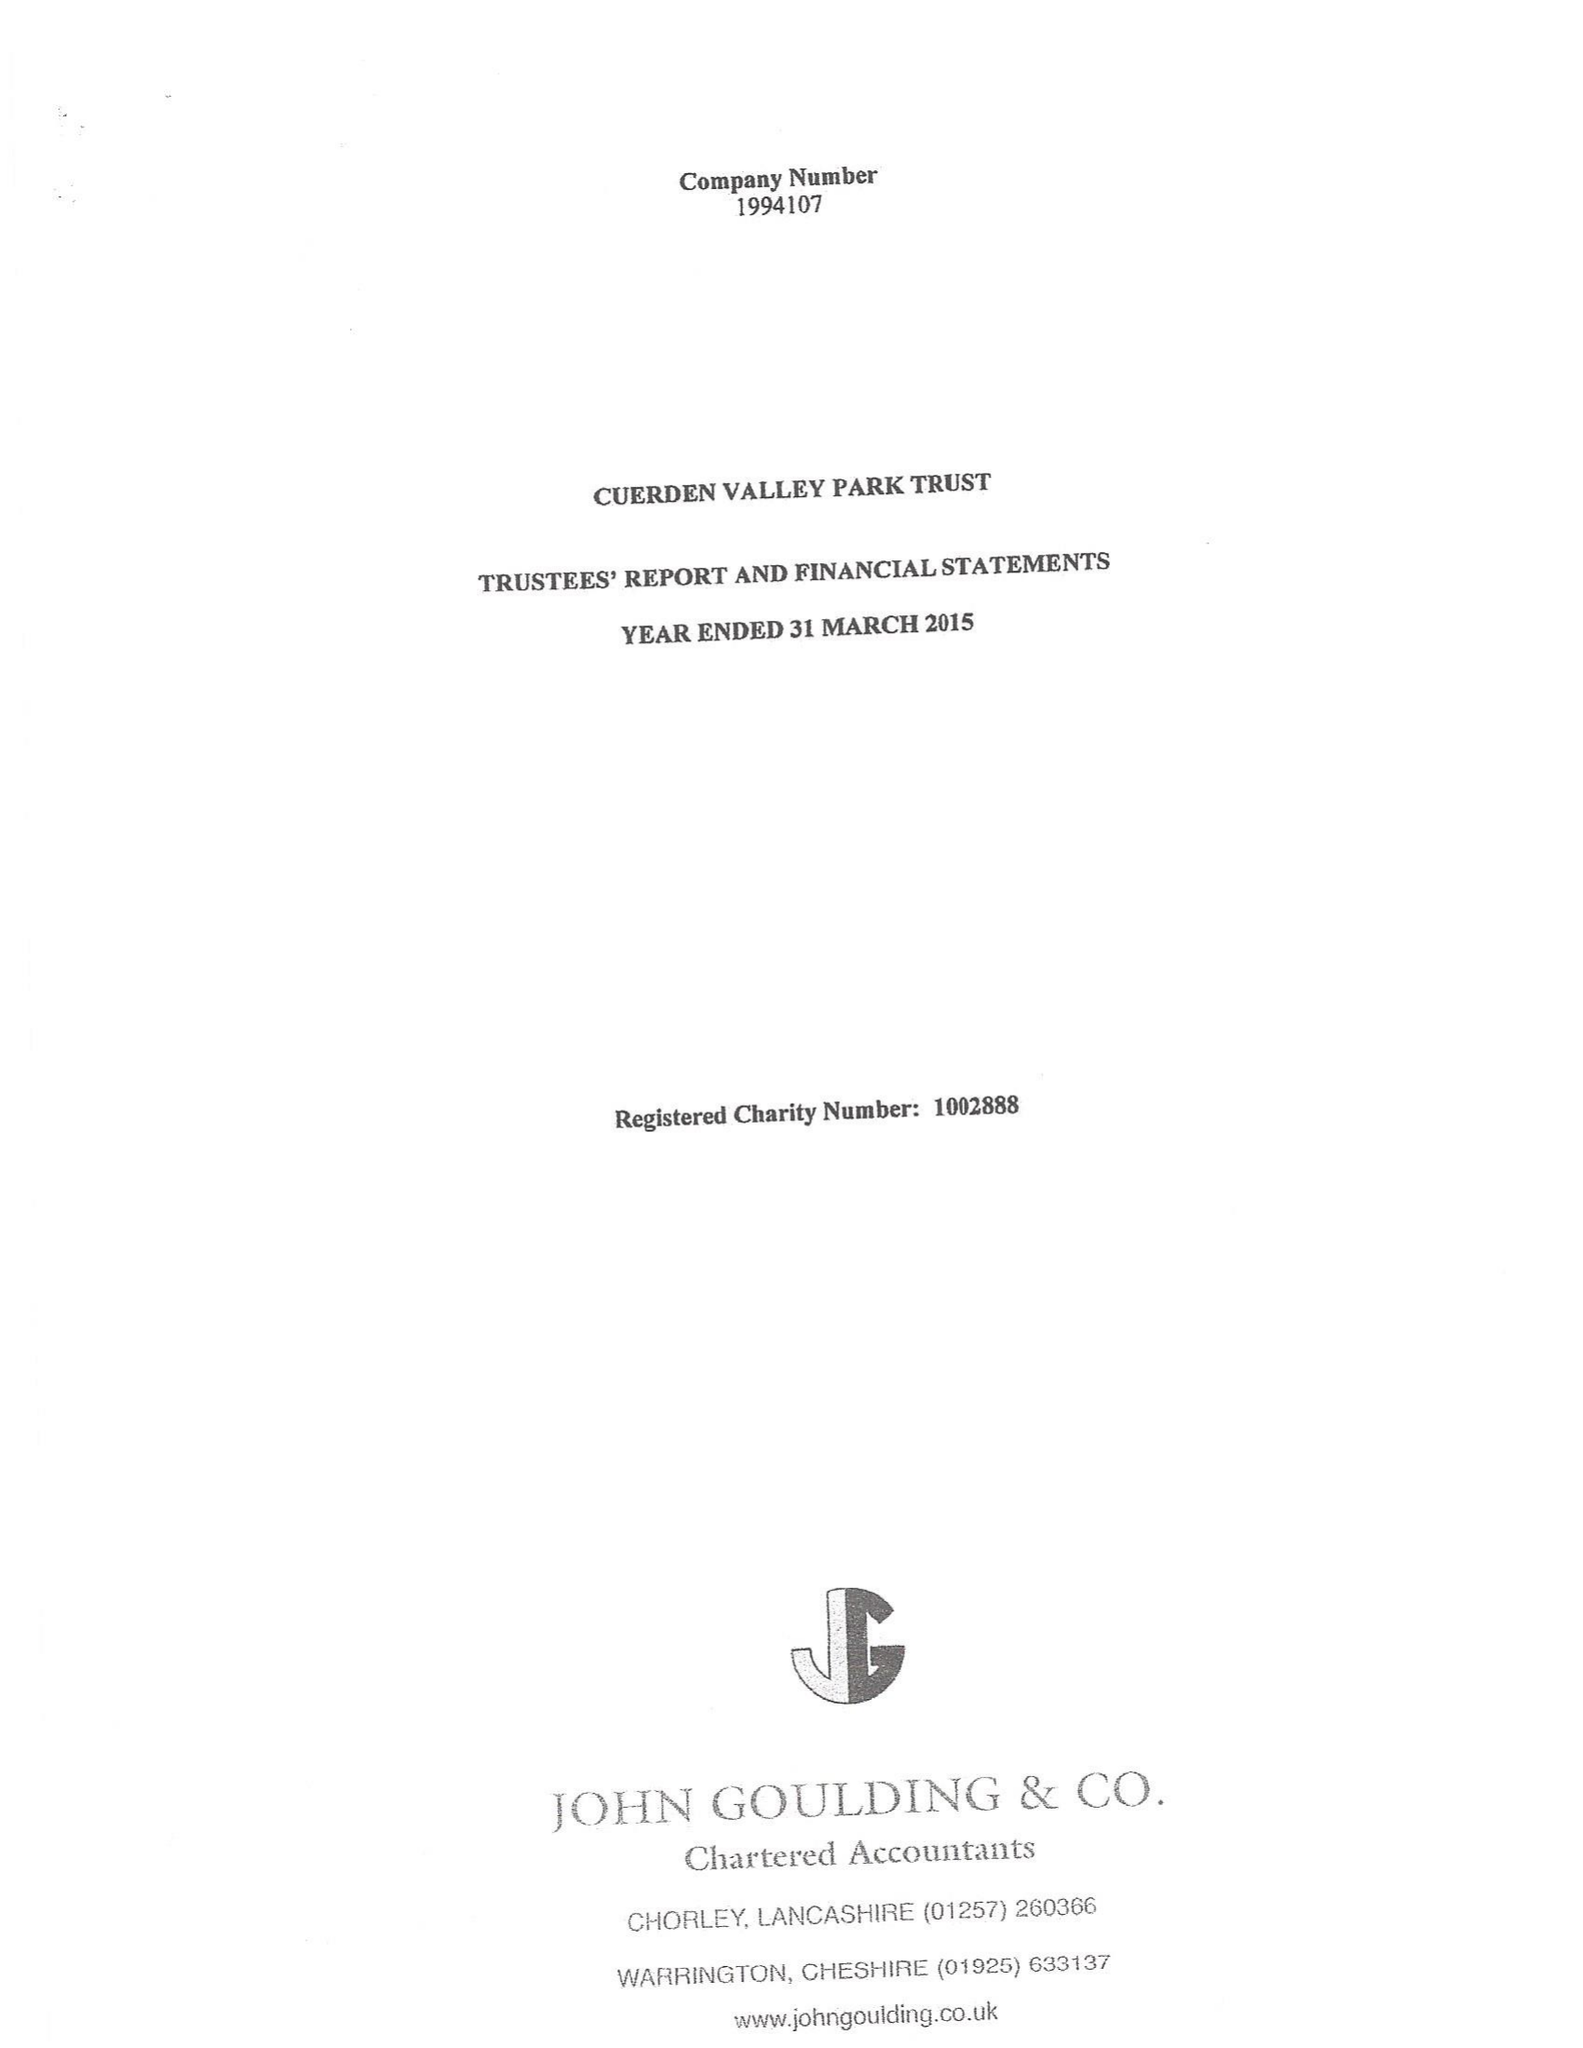What is the value for the charity_name?
Answer the question using a single word or phrase. Cuerden Valley Park Trust 